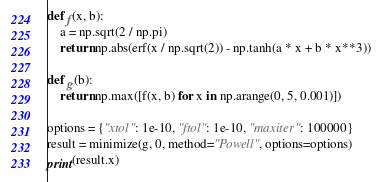<code> <loc_0><loc_0><loc_500><loc_500><_Python_>def f(x, b):
    a = np.sqrt(2 / np.pi)
    return np.abs(erf(x / np.sqrt(2)) - np.tanh(a * x + b * x**3))

def g(b):
    return np.max([f(x, b) for x in np.arange(0, 5, 0.001)])

options = {"xtol": 1e-10, "ftol": 1e-10, "maxiter": 100000}
result = minimize(g, 0, method="Powell", options=options)
print(result.x)
</code> 